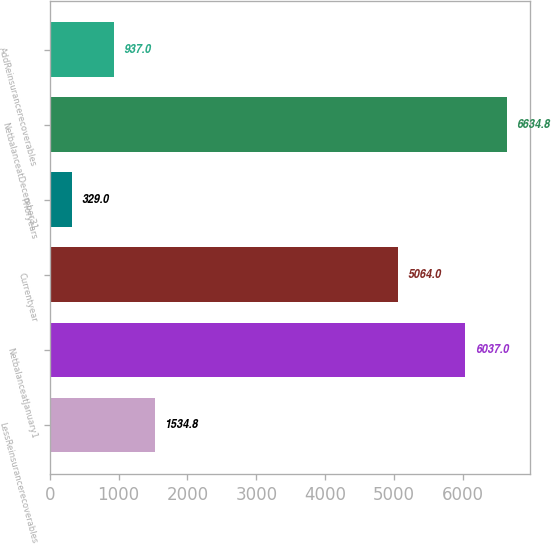Convert chart. <chart><loc_0><loc_0><loc_500><loc_500><bar_chart><fcel>LessReinsurancerecoverables<fcel>NetbalanceatJanuary1<fcel>Currentyear<fcel>Prioryears<fcel>NetbalanceatDecember31<fcel>AddReinsurancerecoverables<nl><fcel>1534.8<fcel>6037<fcel>5064<fcel>329<fcel>6634.8<fcel>937<nl></chart> 